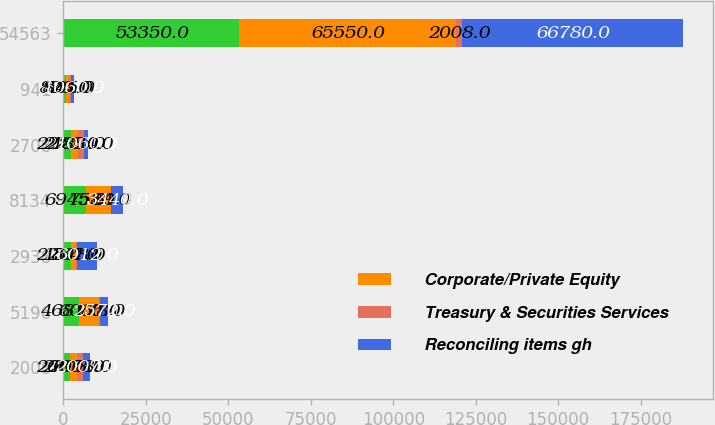Convert chart to OTSL. <chart><loc_0><loc_0><loc_500><loc_500><stacked_bar_chart><ecel><fcel>2008<fcel>5196<fcel>2938<fcel>8134<fcel>2708<fcel>941<fcel>54563<nl><fcel>nan<fcel>2007<fcel>4681<fcel>2264<fcel>6945<fcel>2225<fcel>828<fcel>53350<nl><fcel>Corporate/Private Equity<fcel>2008<fcel>6066<fcel>1518<fcel>7584<fcel>2201<fcel>844<fcel>65550<nl><fcel>Treasury & Securities Services<fcel>2008<fcel>278<fcel>347<fcel>69<fcel>1884<fcel>535<fcel>2008<nl><fcel>Reconciling items gh<fcel>2007<fcel>2572<fcel>6012<fcel>3440<fcel>1060<fcel>1060<fcel>66780<nl></chart> 